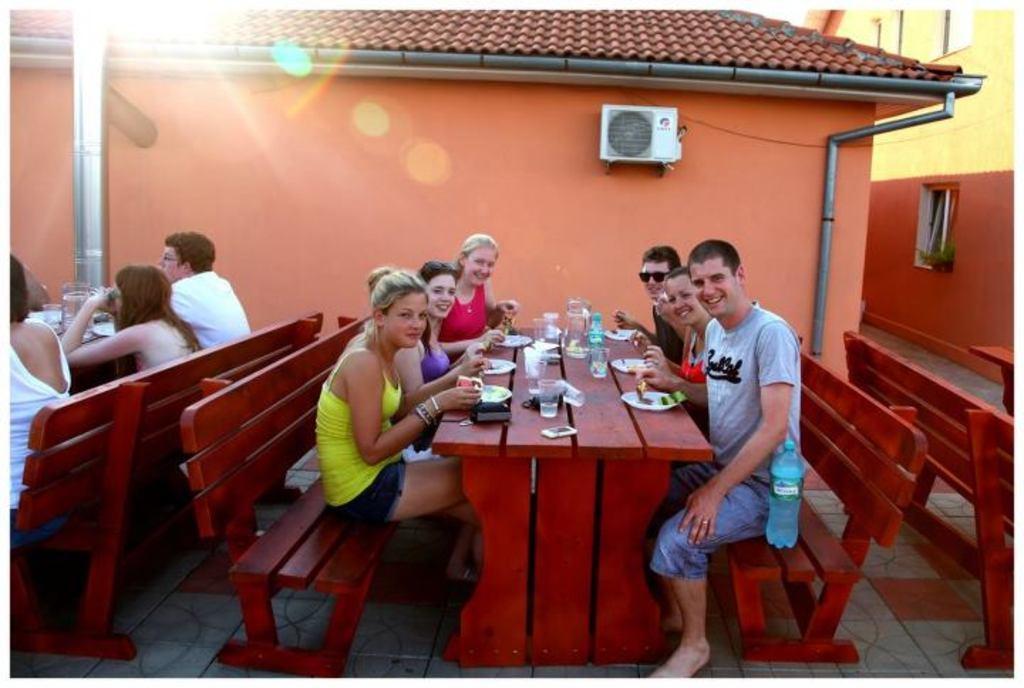How would you summarize this image in a sentence or two? There are some people sitting on the bench in front of a table on which some plates, Water bottles, glasses were placed. There are men and women in this picture. In the background there is a house, condenser and a wall here. 